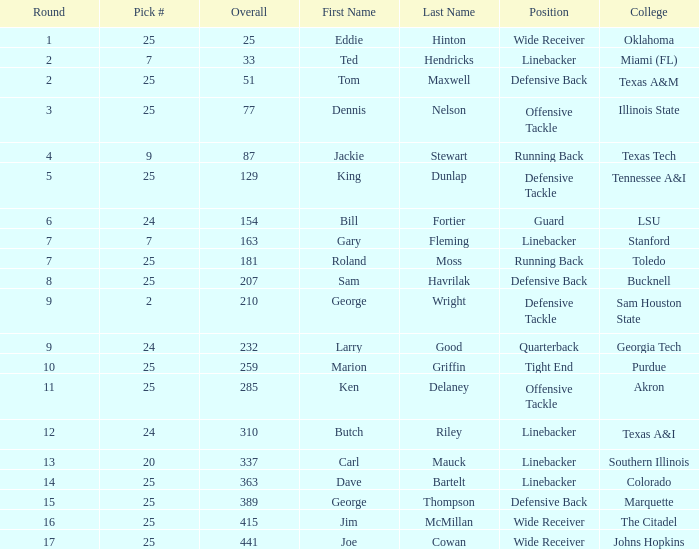Round smaller than 7, and an Overall of 129 is what college? Tennessee A&I. 